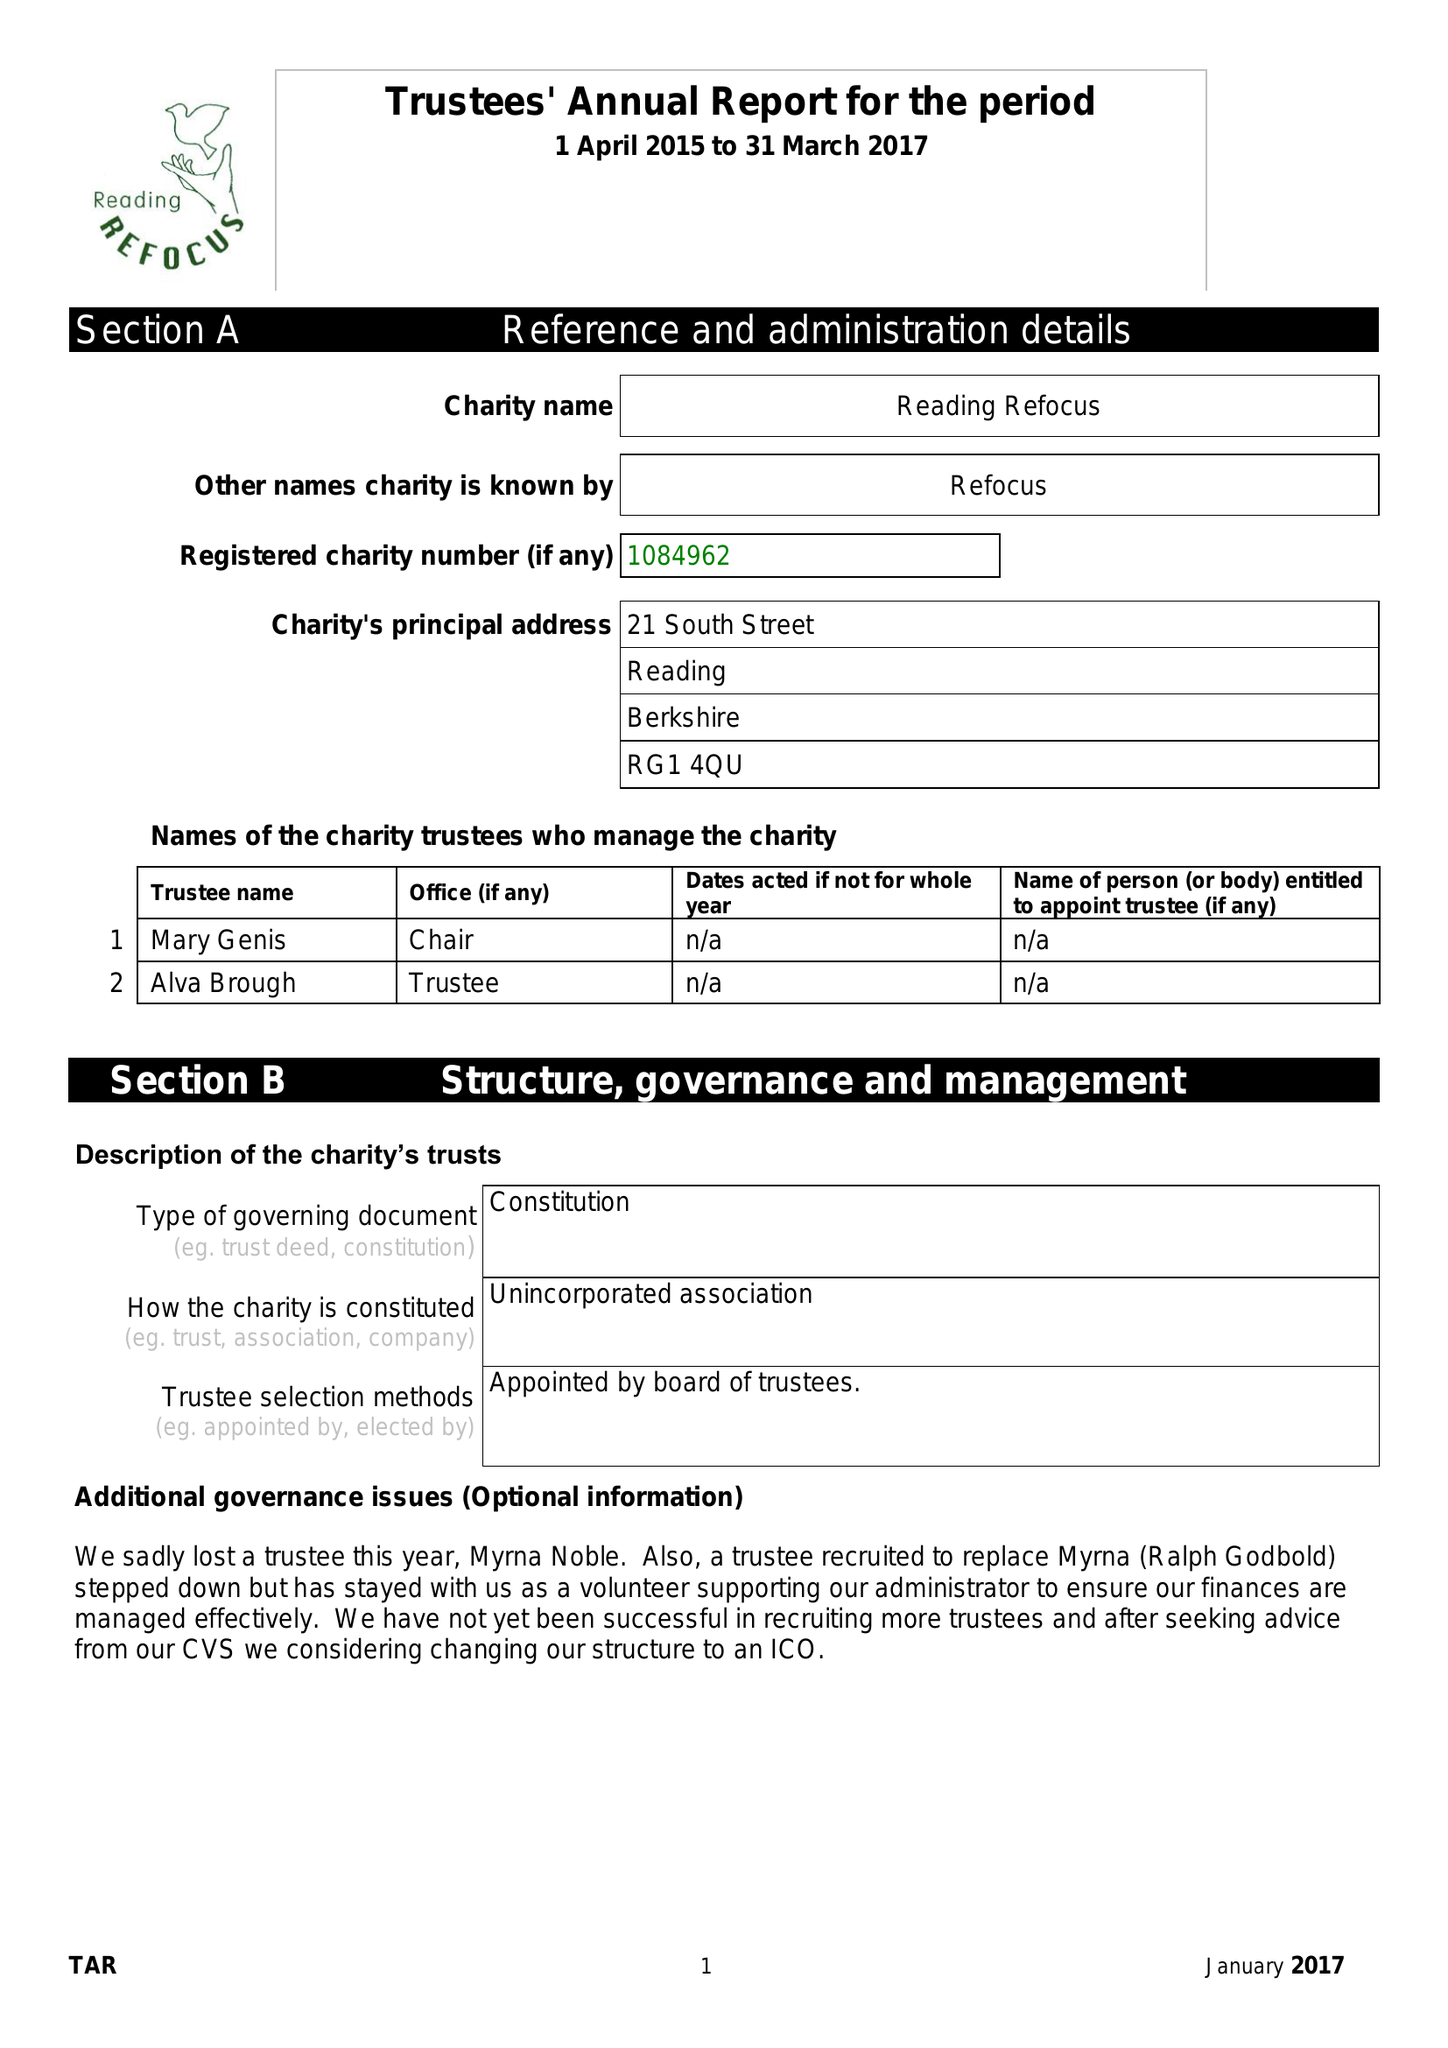What is the value for the income_annually_in_british_pounds?
Answer the question using a single word or phrase. 37023.00 